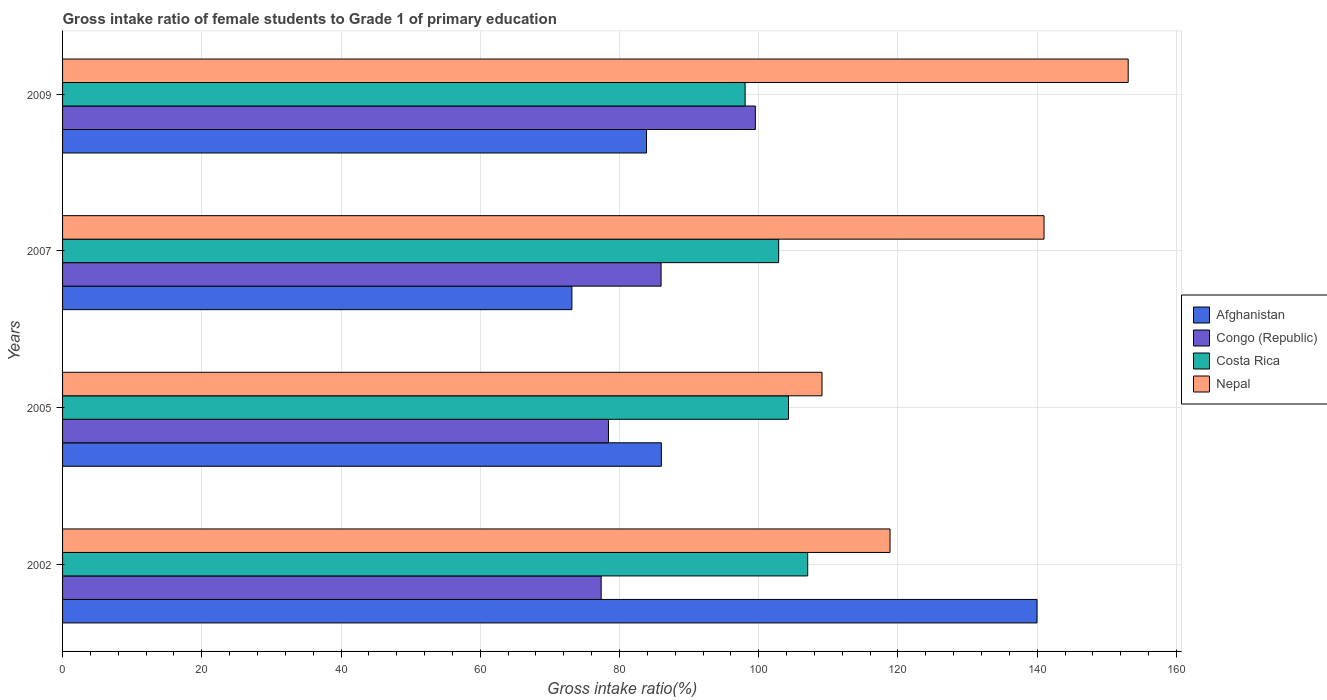How many different coloured bars are there?
Make the answer very short. 4. How many groups of bars are there?
Your answer should be compact. 4. Are the number of bars on each tick of the Y-axis equal?
Provide a succinct answer. Yes. How many bars are there on the 4th tick from the top?
Provide a succinct answer. 4. In how many cases, is the number of bars for a given year not equal to the number of legend labels?
Provide a short and direct response. 0. What is the gross intake ratio in Afghanistan in 2002?
Give a very brief answer. 139.97. Across all years, what is the maximum gross intake ratio in Congo (Republic)?
Give a very brief answer. 99.51. Across all years, what is the minimum gross intake ratio in Costa Rica?
Your answer should be compact. 98.05. In which year was the gross intake ratio in Congo (Republic) maximum?
Offer a very short reply. 2009. In which year was the gross intake ratio in Nepal minimum?
Give a very brief answer. 2005. What is the total gross intake ratio in Nepal in the graph?
Your answer should be very brief. 522. What is the difference between the gross intake ratio in Congo (Republic) in 2005 and that in 2009?
Your answer should be compact. -21.1. What is the difference between the gross intake ratio in Congo (Republic) in 2005 and the gross intake ratio in Afghanistan in 2007?
Keep it short and to the point. 5.25. What is the average gross intake ratio in Afghanistan per year?
Ensure brevity in your answer.  95.76. In the year 2005, what is the difference between the gross intake ratio in Congo (Republic) and gross intake ratio in Nepal?
Make the answer very short. -30.67. What is the ratio of the gross intake ratio in Afghanistan in 2005 to that in 2009?
Your response must be concise. 1.03. What is the difference between the highest and the second highest gross intake ratio in Congo (Republic)?
Give a very brief answer. 13.54. What is the difference between the highest and the lowest gross intake ratio in Costa Rica?
Your answer should be very brief. 8.99. In how many years, is the gross intake ratio in Afghanistan greater than the average gross intake ratio in Afghanistan taken over all years?
Your response must be concise. 1. Is the sum of the gross intake ratio in Afghanistan in 2005 and 2007 greater than the maximum gross intake ratio in Nepal across all years?
Your answer should be compact. Yes. What does the 4th bar from the top in 2009 represents?
Provide a short and direct response. Afghanistan. What does the 2nd bar from the bottom in 2002 represents?
Keep it short and to the point. Congo (Republic). Is it the case that in every year, the sum of the gross intake ratio in Nepal and gross intake ratio in Costa Rica is greater than the gross intake ratio in Afghanistan?
Provide a succinct answer. Yes. Are all the bars in the graph horizontal?
Your answer should be very brief. Yes. How many years are there in the graph?
Offer a very short reply. 4. Are the values on the major ticks of X-axis written in scientific E-notation?
Provide a short and direct response. No. Does the graph contain any zero values?
Provide a succinct answer. No. Does the graph contain grids?
Provide a succinct answer. Yes. How many legend labels are there?
Make the answer very short. 4. What is the title of the graph?
Give a very brief answer. Gross intake ratio of female students to Grade 1 of primary education. What is the label or title of the X-axis?
Offer a terse response. Gross intake ratio(%). What is the label or title of the Y-axis?
Make the answer very short. Years. What is the Gross intake ratio(%) of Afghanistan in 2002?
Keep it short and to the point. 139.97. What is the Gross intake ratio(%) in Congo (Republic) in 2002?
Your answer should be very brief. 77.37. What is the Gross intake ratio(%) of Costa Rica in 2002?
Offer a very short reply. 107.03. What is the Gross intake ratio(%) of Nepal in 2002?
Your answer should be very brief. 118.86. What is the Gross intake ratio(%) of Afghanistan in 2005?
Make the answer very short. 86.01. What is the Gross intake ratio(%) in Congo (Republic) in 2005?
Give a very brief answer. 78.42. What is the Gross intake ratio(%) of Costa Rica in 2005?
Make the answer very short. 104.27. What is the Gross intake ratio(%) of Nepal in 2005?
Keep it short and to the point. 109.09. What is the Gross intake ratio(%) in Afghanistan in 2007?
Provide a short and direct response. 73.16. What is the Gross intake ratio(%) of Congo (Republic) in 2007?
Offer a terse response. 85.97. What is the Gross intake ratio(%) of Costa Rica in 2007?
Your answer should be compact. 102.86. What is the Gross intake ratio(%) in Nepal in 2007?
Make the answer very short. 140.98. What is the Gross intake ratio(%) of Afghanistan in 2009?
Make the answer very short. 83.88. What is the Gross intake ratio(%) in Congo (Republic) in 2009?
Offer a very short reply. 99.51. What is the Gross intake ratio(%) of Costa Rica in 2009?
Give a very brief answer. 98.05. What is the Gross intake ratio(%) of Nepal in 2009?
Ensure brevity in your answer.  153.07. Across all years, what is the maximum Gross intake ratio(%) in Afghanistan?
Your answer should be very brief. 139.97. Across all years, what is the maximum Gross intake ratio(%) in Congo (Republic)?
Offer a terse response. 99.51. Across all years, what is the maximum Gross intake ratio(%) of Costa Rica?
Your answer should be compact. 107.03. Across all years, what is the maximum Gross intake ratio(%) of Nepal?
Make the answer very short. 153.07. Across all years, what is the minimum Gross intake ratio(%) in Afghanistan?
Give a very brief answer. 73.16. Across all years, what is the minimum Gross intake ratio(%) of Congo (Republic)?
Your answer should be very brief. 77.37. Across all years, what is the minimum Gross intake ratio(%) in Costa Rica?
Your response must be concise. 98.05. Across all years, what is the minimum Gross intake ratio(%) of Nepal?
Offer a terse response. 109.09. What is the total Gross intake ratio(%) in Afghanistan in the graph?
Offer a terse response. 383.03. What is the total Gross intake ratio(%) of Congo (Republic) in the graph?
Ensure brevity in your answer.  341.27. What is the total Gross intake ratio(%) of Costa Rica in the graph?
Make the answer very short. 412.21. What is the total Gross intake ratio(%) of Nepal in the graph?
Offer a terse response. 522. What is the difference between the Gross intake ratio(%) in Afghanistan in 2002 and that in 2005?
Keep it short and to the point. 53.96. What is the difference between the Gross intake ratio(%) in Congo (Republic) in 2002 and that in 2005?
Your answer should be very brief. -1.05. What is the difference between the Gross intake ratio(%) of Costa Rica in 2002 and that in 2005?
Your response must be concise. 2.76. What is the difference between the Gross intake ratio(%) in Nepal in 2002 and that in 2005?
Your response must be concise. 9.77. What is the difference between the Gross intake ratio(%) of Afghanistan in 2002 and that in 2007?
Keep it short and to the point. 66.81. What is the difference between the Gross intake ratio(%) of Congo (Republic) in 2002 and that in 2007?
Provide a short and direct response. -8.61. What is the difference between the Gross intake ratio(%) of Costa Rica in 2002 and that in 2007?
Offer a very short reply. 4.17. What is the difference between the Gross intake ratio(%) of Nepal in 2002 and that in 2007?
Make the answer very short. -22.12. What is the difference between the Gross intake ratio(%) in Afghanistan in 2002 and that in 2009?
Your answer should be compact. 56.09. What is the difference between the Gross intake ratio(%) of Congo (Republic) in 2002 and that in 2009?
Your answer should be compact. -22.15. What is the difference between the Gross intake ratio(%) of Costa Rica in 2002 and that in 2009?
Provide a succinct answer. 8.99. What is the difference between the Gross intake ratio(%) of Nepal in 2002 and that in 2009?
Your response must be concise. -34.21. What is the difference between the Gross intake ratio(%) in Afghanistan in 2005 and that in 2007?
Your answer should be compact. 12.85. What is the difference between the Gross intake ratio(%) of Congo (Republic) in 2005 and that in 2007?
Your answer should be compact. -7.56. What is the difference between the Gross intake ratio(%) of Costa Rica in 2005 and that in 2007?
Your answer should be very brief. 1.41. What is the difference between the Gross intake ratio(%) in Nepal in 2005 and that in 2007?
Your answer should be compact. -31.89. What is the difference between the Gross intake ratio(%) in Afghanistan in 2005 and that in 2009?
Make the answer very short. 2.13. What is the difference between the Gross intake ratio(%) in Congo (Republic) in 2005 and that in 2009?
Make the answer very short. -21.1. What is the difference between the Gross intake ratio(%) of Costa Rica in 2005 and that in 2009?
Give a very brief answer. 6.23. What is the difference between the Gross intake ratio(%) of Nepal in 2005 and that in 2009?
Offer a very short reply. -43.98. What is the difference between the Gross intake ratio(%) of Afghanistan in 2007 and that in 2009?
Your response must be concise. -10.72. What is the difference between the Gross intake ratio(%) in Congo (Republic) in 2007 and that in 2009?
Provide a short and direct response. -13.54. What is the difference between the Gross intake ratio(%) in Costa Rica in 2007 and that in 2009?
Your answer should be compact. 4.82. What is the difference between the Gross intake ratio(%) of Nepal in 2007 and that in 2009?
Your answer should be compact. -12.09. What is the difference between the Gross intake ratio(%) of Afghanistan in 2002 and the Gross intake ratio(%) of Congo (Republic) in 2005?
Make the answer very short. 61.56. What is the difference between the Gross intake ratio(%) of Afghanistan in 2002 and the Gross intake ratio(%) of Costa Rica in 2005?
Keep it short and to the point. 35.7. What is the difference between the Gross intake ratio(%) in Afghanistan in 2002 and the Gross intake ratio(%) in Nepal in 2005?
Your answer should be compact. 30.89. What is the difference between the Gross intake ratio(%) in Congo (Republic) in 2002 and the Gross intake ratio(%) in Costa Rica in 2005?
Your response must be concise. -26.91. What is the difference between the Gross intake ratio(%) of Congo (Republic) in 2002 and the Gross intake ratio(%) of Nepal in 2005?
Your answer should be very brief. -31.72. What is the difference between the Gross intake ratio(%) of Costa Rica in 2002 and the Gross intake ratio(%) of Nepal in 2005?
Your answer should be compact. -2.06. What is the difference between the Gross intake ratio(%) in Afghanistan in 2002 and the Gross intake ratio(%) in Congo (Republic) in 2007?
Ensure brevity in your answer.  54. What is the difference between the Gross intake ratio(%) in Afghanistan in 2002 and the Gross intake ratio(%) in Costa Rica in 2007?
Offer a terse response. 37.11. What is the difference between the Gross intake ratio(%) of Afghanistan in 2002 and the Gross intake ratio(%) of Nepal in 2007?
Offer a very short reply. -1.01. What is the difference between the Gross intake ratio(%) in Congo (Republic) in 2002 and the Gross intake ratio(%) in Costa Rica in 2007?
Offer a terse response. -25.49. What is the difference between the Gross intake ratio(%) in Congo (Republic) in 2002 and the Gross intake ratio(%) in Nepal in 2007?
Your answer should be compact. -63.62. What is the difference between the Gross intake ratio(%) in Costa Rica in 2002 and the Gross intake ratio(%) in Nepal in 2007?
Keep it short and to the point. -33.95. What is the difference between the Gross intake ratio(%) of Afghanistan in 2002 and the Gross intake ratio(%) of Congo (Republic) in 2009?
Provide a short and direct response. 40.46. What is the difference between the Gross intake ratio(%) in Afghanistan in 2002 and the Gross intake ratio(%) in Costa Rica in 2009?
Keep it short and to the point. 41.93. What is the difference between the Gross intake ratio(%) of Afghanistan in 2002 and the Gross intake ratio(%) of Nepal in 2009?
Provide a short and direct response. -13.1. What is the difference between the Gross intake ratio(%) in Congo (Republic) in 2002 and the Gross intake ratio(%) in Costa Rica in 2009?
Ensure brevity in your answer.  -20.68. What is the difference between the Gross intake ratio(%) in Congo (Republic) in 2002 and the Gross intake ratio(%) in Nepal in 2009?
Give a very brief answer. -75.7. What is the difference between the Gross intake ratio(%) of Costa Rica in 2002 and the Gross intake ratio(%) of Nepal in 2009?
Make the answer very short. -46.04. What is the difference between the Gross intake ratio(%) in Afghanistan in 2005 and the Gross intake ratio(%) in Congo (Republic) in 2007?
Your answer should be compact. 0.04. What is the difference between the Gross intake ratio(%) of Afghanistan in 2005 and the Gross intake ratio(%) of Costa Rica in 2007?
Give a very brief answer. -16.85. What is the difference between the Gross intake ratio(%) in Afghanistan in 2005 and the Gross intake ratio(%) in Nepal in 2007?
Ensure brevity in your answer.  -54.97. What is the difference between the Gross intake ratio(%) of Congo (Republic) in 2005 and the Gross intake ratio(%) of Costa Rica in 2007?
Your response must be concise. -24.45. What is the difference between the Gross intake ratio(%) of Congo (Republic) in 2005 and the Gross intake ratio(%) of Nepal in 2007?
Your response must be concise. -62.57. What is the difference between the Gross intake ratio(%) of Costa Rica in 2005 and the Gross intake ratio(%) of Nepal in 2007?
Ensure brevity in your answer.  -36.71. What is the difference between the Gross intake ratio(%) of Afghanistan in 2005 and the Gross intake ratio(%) of Congo (Republic) in 2009?
Offer a terse response. -13.5. What is the difference between the Gross intake ratio(%) of Afghanistan in 2005 and the Gross intake ratio(%) of Costa Rica in 2009?
Keep it short and to the point. -12.03. What is the difference between the Gross intake ratio(%) in Afghanistan in 2005 and the Gross intake ratio(%) in Nepal in 2009?
Provide a short and direct response. -67.06. What is the difference between the Gross intake ratio(%) in Congo (Republic) in 2005 and the Gross intake ratio(%) in Costa Rica in 2009?
Provide a succinct answer. -19.63. What is the difference between the Gross intake ratio(%) of Congo (Republic) in 2005 and the Gross intake ratio(%) of Nepal in 2009?
Ensure brevity in your answer.  -74.66. What is the difference between the Gross intake ratio(%) in Costa Rica in 2005 and the Gross intake ratio(%) in Nepal in 2009?
Keep it short and to the point. -48.8. What is the difference between the Gross intake ratio(%) in Afghanistan in 2007 and the Gross intake ratio(%) in Congo (Republic) in 2009?
Provide a succinct answer. -26.35. What is the difference between the Gross intake ratio(%) in Afghanistan in 2007 and the Gross intake ratio(%) in Costa Rica in 2009?
Offer a very short reply. -24.88. What is the difference between the Gross intake ratio(%) in Afghanistan in 2007 and the Gross intake ratio(%) in Nepal in 2009?
Keep it short and to the point. -79.91. What is the difference between the Gross intake ratio(%) in Congo (Republic) in 2007 and the Gross intake ratio(%) in Costa Rica in 2009?
Provide a short and direct response. -12.07. What is the difference between the Gross intake ratio(%) in Congo (Republic) in 2007 and the Gross intake ratio(%) in Nepal in 2009?
Your response must be concise. -67.1. What is the difference between the Gross intake ratio(%) of Costa Rica in 2007 and the Gross intake ratio(%) of Nepal in 2009?
Your answer should be very brief. -50.21. What is the average Gross intake ratio(%) in Afghanistan per year?
Ensure brevity in your answer.  95.76. What is the average Gross intake ratio(%) of Congo (Republic) per year?
Your answer should be very brief. 85.32. What is the average Gross intake ratio(%) in Costa Rica per year?
Offer a terse response. 103.05. What is the average Gross intake ratio(%) in Nepal per year?
Keep it short and to the point. 130.5. In the year 2002, what is the difference between the Gross intake ratio(%) in Afghanistan and Gross intake ratio(%) in Congo (Republic)?
Your answer should be very brief. 62.61. In the year 2002, what is the difference between the Gross intake ratio(%) of Afghanistan and Gross intake ratio(%) of Costa Rica?
Keep it short and to the point. 32.94. In the year 2002, what is the difference between the Gross intake ratio(%) of Afghanistan and Gross intake ratio(%) of Nepal?
Your response must be concise. 21.12. In the year 2002, what is the difference between the Gross intake ratio(%) in Congo (Republic) and Gross intake ratio(%) in Costa Rica?
Offer a very short reply. -29.66. In the year 2002, what is the difference between the Gross intake ratio(%) of Congo (Republic) and Gross intake ratio(%) of Nepal?
Provide a succinct answer. -41.49. In the year 2002, what is the difference between the Gross intake ratio(%) of Costa Rica and Gross intake ratio(%) of Nepal?
Offer a terse response. -11.83. In the year 2005, what is the difference between the Gross intake ratio(%) of Afghanistan and Gross intake ratio(%) of Congo (Republic)?
Provide a short and direct response. 7.6. In the year 2005, what is the difference between the Gross intake ratio(%) in Afghanistan and Gross intake ratio(%) in Costa Rica?
Provide a succinct answer. -18.26. In the year 2005, what is the difference between the Gross intake ratio(%) of Afghanistan and Gross intake ratio(%) of Nepal?
Your answer should be very brief. -23.07. In the year 2005, what is the difference between the Gross intake ratio(%) of Congo (Republic) and Gross intake ratio(%) of Costa Rica?
Your answer should be very brief. -25.86. In the year 2005, what is the difference between the Gross intake ratio(%) of Congo (Republic) and Gross intake ratio(%) of Nepal?
Your answer should be very brief. -30.67. In the year 2005, what is the difference between the Gross intake ratio(%) of Costa Rica and Gross intake ratio(%) of Nepal?
Offer a terse response. -4.81. In the year 2007, what is the difference between the Gross intake ratio(%) of Afghanistan and Gross intake ratio(%) of Congo (Republic)?
Your answer should be very brief. -12.81. In the year 2007, what is the difference between the Gross intake ratio(%) of Afghanistan and Gross intake ratio(%) of Costa Rica?
Provide a short and direct response. -29.7. In the year 2007, what is the difference between the Gross intake ratio(%) in Afghanistan and Gross intake ratio(%) in Nepal?
Offer a very short reply. -67.82. In the year 2007, what is the difference between the Gross intake ratio(%) of Congo (Republic) and Gross intake ratio(%) of Costa Rica?
Offer a very short reply. -16.89. In the year 2007, what is the difference between the Gross intake ratio(%) of Congo (Republic) and Gross intake ratio(%) of Nepal?
Give a very brief answer. -55.01. In the year 2007, what is the difference between the Gross intake ratio(%) of Costa Rica and Gross intake ratio(%) of Nepal?
Your answer should be very brief. -38.12. In the year 2009, what is the difference between the Gross intake ratio(%) in Afghanistan and Gross intake ratio(%) in Congo (Republic)?
Keep it short and to the point. -15.63. In the year 2009, what is the difference between the Gross intake ratio(%) in Afghanistan and Gross intake ratio(%) in Costa Rica?
Provide a succinct answer. -14.16. In the year 2009, what is the difference between the Gross intake ratio(%) of Afghanistan and Gross intake ratio(%) of Nepal?
Give a very brief answer. -69.19. In the year 2009, what is the difference between the Gross intake ratio(%) of Congo (Republic) and Gross intake ratio(%) of Costa Rica?
Keep it short and to the point. 1.47. In the year 2009, what is the difference between the Gross intake ratio(%) in Congo (Republic) and Gross intake ratio(%) in Nepal?
Ensure brevity in your answer.  -53.56. In the year 2009, what is the difference between the Gross intake ratio(%) of Costa Rica and Gross intake ratio(%) of Nepal?
Give a very brief answer. -55.03. What is the ratio of the Gross intake ratio(%) in Afghanistan in 2002 to that in 2005?
Your response must be concise. 1.63. What is the ratio of the Gross intake ratio(%) in Congo (Republic) in 2002 to that in 2005?
Your response must be concise. 0.99. What is the ratio of the Gross intake ratio(%) of Costa Rica in 2002 to that in 2005?
Provide a succinct answer. 1.03. What is the ratio of the Gross intake ratio(%) in Nepal in 2002 to that in 2005?
Keep it short and to the point. 1.09. What is the ratio of the Gross intake ratio(%) in Afghanistan in 2002 to that in 2007?
Your response must be concise. 1.91. What is the ratio of the Gross intake ratio(%) of Congo (Republic) in 2002 to that in 2007?
Keep it short and to the point. 0.9. What is the ratio of the Gross intake ratio(%) of Costa Rica in 2002 to that in 2007?
Provide a succinct answer. 1.04. What is the ratio of the Gross intake ratio(%) in Nepal in 2002 to that in 2007?
Keep it short and to the point. 0.84. What is the ratio of the Gross intake ratio(%) of Afghanistan in 2002 to that in 2009?
Keep it short and to the point. 1.67. What is the ratio of the Gross intake ratio(%) in Congo (Republic) in 2002 to that in 2009?
Offer a very short reply. 0.78. What is the ratio of the Gross intake ratio(%) of Costa Rica in 2002 to that in 2009?
Your response must be concise. 1.09. What is the ratio of the Gross intake ratio(%) of Nepal in 2002 to that in 2009?
Your response must be concise. 0.78. What is the ratio of the Gross intake ratio(%) of Afghanistan in 2005 to that in 2007?
Provide a short and direct response. 1.18. What is the ratio of the Gross intake ratio(%) in Congo (Republic) in 2005 to that in 2007?
Provide a short and direct response. 0.91. What is the ratio of the Gross intake ratio(%) of Costa Rica in 2005 to that in 2007?
Your response must be concise. 1.01. What is the ratio of the Gross intake ratio(%) of Nepal in 2005 to that in 2007?
Give a very brief answer. 0.77. What is the ratio of the Gross intake ratio(%) in Afghanistan in 2005 to that in 2009?
Your answer should be compact. 1.03. What is the ratio of the Gross intake ratio(%) in Congo (Republic) in 2005 to that in 2009?
Provide a succinct answer. 0.79. What is the ratio of the Gross intake ratio(%) of Costa Rica in 2005 to that in 2009?
Keep it short and to the point. 1.06. What is the ratio of the Gross intake ratio(%) of Nepal in 2005 to that in 2009?
Offer a very short reply. 0.71. What is the ratio of the Gross intake ratio(%) of Afghanistan in 2007 to that in 2009?
Your response must be concise. 0.87. What is the ratio of the Gross intake ratio(%) in Congo (Republic) in 2007 to that in 2009?
Offer a terse response. 0.86. What is the ratio of the Gross intake ratio(%) in Costa Rica in 2007 to that in 2009?
Your response must be concise. 1.05. What is the ratio of the Gross intake ratio(%) of Nepal in 2007 to that in 2009?
Give a very brief answer. 0.92. What is the difference between the highest and the second highest Gross intake ratio(%) of Afghanistan?
Your response must be concise. 53.96. What is the difference between the highest and the second highest Gross intake ratio(%) in Congo (Republic)?
Your response must be concise. 13.54. What is the difference between the highest and the second highest Gross intake ratio(%) of Costa Rica?
Ensure brevity in your answer.  2.76. What is the difference between the highest and the second highest Gross intake ratio(%) of Nepal?
Offer a terse response. 12.09. What is the difference between the highest and the lowest Gross intake ratio(%) in Afghanistan?
Your response must be concise. 66.81. What is the difference between the highest and the lowest Gross intake ratio(%) of Congo (Republic)?
Provide a short and direct response. 22.15. What is the difference between the highest and the lowest Gross intake ratio(%) of Costa Rica?
Your answer should be compact. 8.99. What is the difference between the highest and the lowest Gross intake ratio(%) in Nepal?
Offer a terse response. 43.98. 